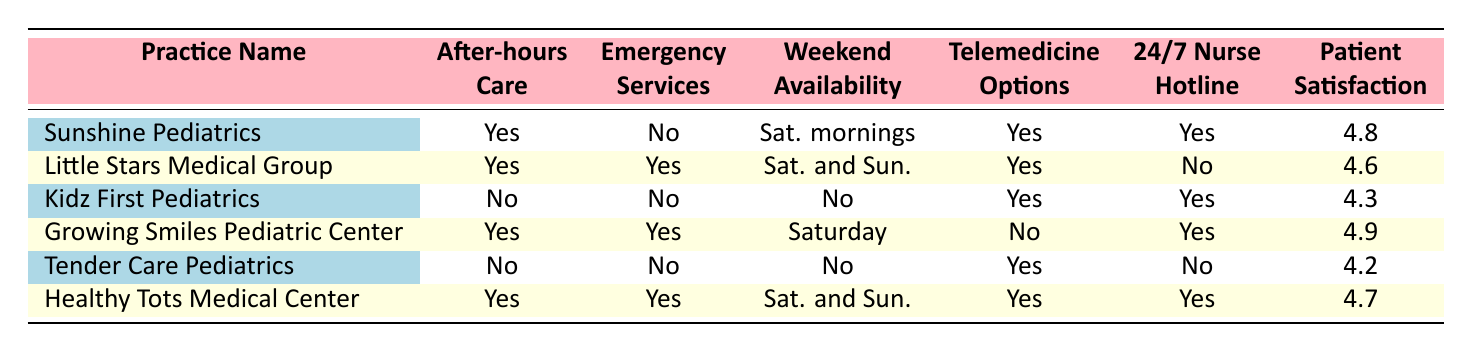What pediatric practices offer after-hours care? From the table, I can see that Sunshine Pediatrics, Little Stars Medical Group, Growing Smiles Pediatric Center, and Healthy Tots Medical Center all indicate "Yes" under the after-hours care column.
Answer: Sunshine Pediatrics, Little Stars Medical Group, Growing Smiles Pediatric Center, Healthy Tots Medical Center Which practice has the highest patient satisfaction rating? The table shows the patient satisfaction ratings for each practice. The highest rating is 4.9 for Growing Smiles Pediatric Center.
Answer: Growing Smiles Pediatric Center Is there a pediatric practice that offers emergency services but does not provide after-hours care? By checking the table, I can see that all practices that offer emergency services (Little Stars Medical Group, Growing Smiles Pediatric Center, and Healthy Tots Medical Center) also provide after-hours care. Therefore, the answer is no.
Answer: No What is the average distance of all practices from home? To find the average distance, I sum the distances (3.2 + 5.7 + 2.1 + 4.5 + 1.8 + 6.3 = 23.6) and divide by the number of practices (6). So, 23.6 / 6 = 3.93.
Answer: 3.93 Which practice has no weekend availability but provides telemedicine options? Looking at the weekend availability column, Kidz First Pediatrics and Tender Care Pediatrics both have "No" for weekend availability. Among these, Kidz First Pediatrics offers telemedicine options while Tender Care Pediatrics also does.
Answer: Kidz First Pediatrics, Tender Care Pediatrics 